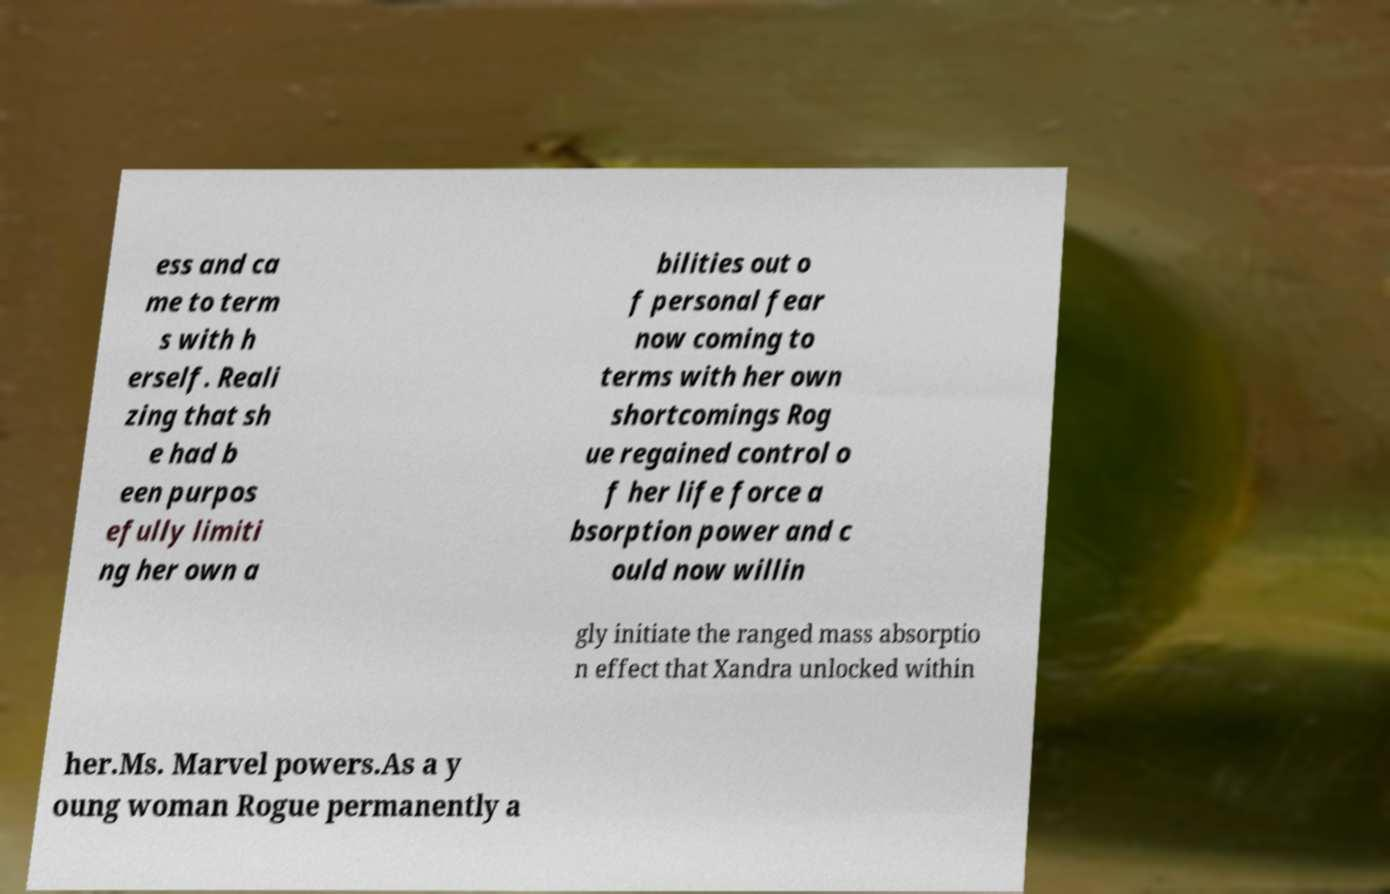There's text embedded in this image that I need extracted. Can you transcribe it verbatim? ess and ca me to term s with h erself. Reali zing that sh e had b een purpos efully limiti ng her own a bilities out o f personal fear now coming to terms with her own shortcomings Rog ue regained control o f her life force a bsorption power and c ould now willin gly initiate the ranged mass absorptio n effect that Xandra unlocked within her.Ms. Marvel powers.As a y oung woman Rogue permanently a 